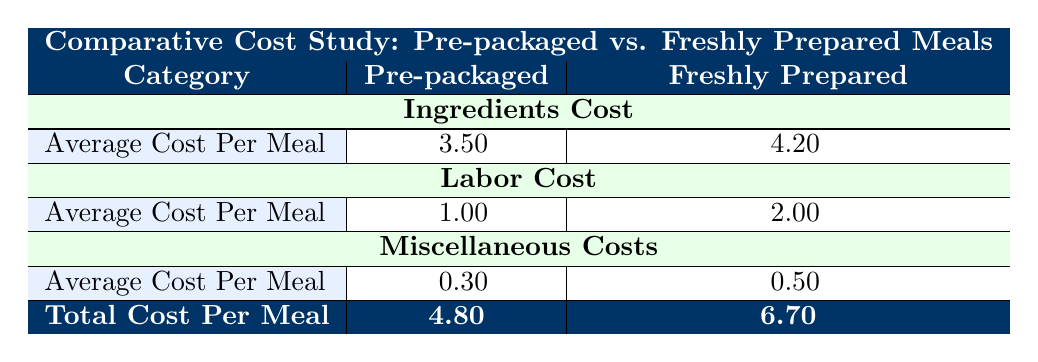What is the average cost per meal for Pre-packaged Meals? The average cost per meal for Pre-packaged Meals is listed in the corresponding row under the Pre-packaged column. It is explicitly shown as 3.50.
Answer: 3.50 What is the total cost per meal for Freshly Prepared Meals? The total cost per meal for Freshly Prepared Meals can be found in the final row under the Freshly Prepared column, which shows a total of 6.70.
Answer: 6.70 Is the average labor cost for Pre-packaged Meals lower than that for Freshly Prepared Meals? The average labor cost for Pre-packaged Meals is 1.00, while for Freshly Prepared Meals, it is 2.00. Since 1.00 is less than 2.00, the statement is true.
Answer: Yes What is the difference in total cost per meal between Pre-packaged and Freshly Prepared Meals? To find the difference, subtract the total cost for Pre-packaged Meals (4.80) from the total cost for Freshly Prepared Meals (6.70). The difference is calculated as 6.70 - 4.80 = 1.90.
Answer: 1.90 What is the average cost of ingredients for Freshly Prepared Meals? The average cost of ingredients for Freshly Prepared Meals is explicitly stated under the Ingredients Cost category in the table, which is 4.20.
Answer: 4.20 Do Pre-packaged Meals incur higher miscellaneous costs compared to Freshly Prepared Meals? The miscellaneous cost for Pre-packaged Meals is 0.30, whereas the cost for Freshly Prepared Meals is 0.50. Since 0.30 is less than 0.50, the statement is false.
Answer: No What is the total of the ingredients cost breakdown for Freshly Prepared Meals? To find the total, we sum the costs of Fresh Vegetables (1.20), Lean Meat (2.00), Fresh Fruit (0.60), and Homemade Juice (0.40): 1.20 + 2.00 + 0.60 + 0.40 = 4.20.
Answer: 4.20 How does the total cost for Pre-packaged Meals compare to the total cost for Freshly Prepared Meals? The total cost for Pre-packaged Meals is 4.80, and for Freshly Prepared Meals, it is 6.70. Since 4.80 is less than 6.70, the total cost for Pre-packaged Meals is lower.
Answer: Lower What is the average cost per meal for the miscellaneous costs category? The average cost per meal for Pre-packaged Meals in the miscellaneous costs category is 0.30, and for Freshly Prepared Meals, it is 0.50. To find the average, combine these two values: (0.30 + 0.50) / 2 = 0.40.
Answer: 0.40 